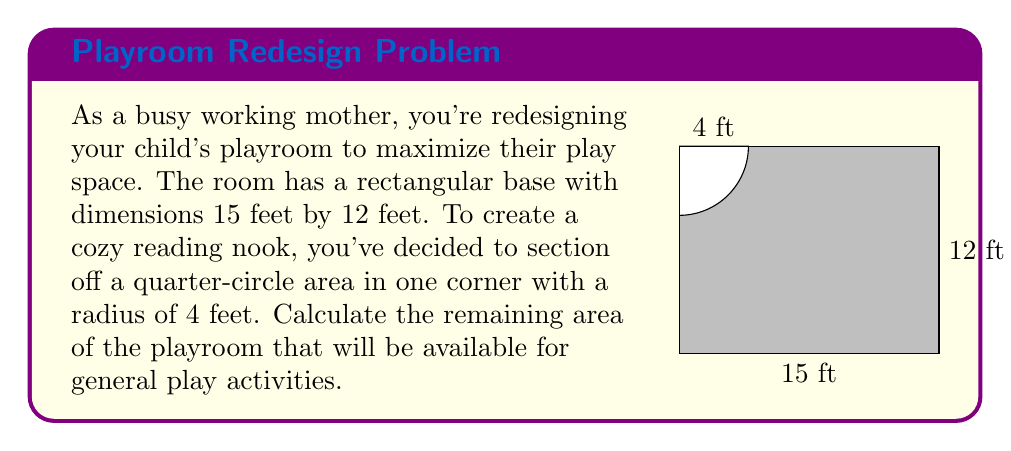Show me your answer to this math problem. Let's approach this problem step-by-step:

1) First, calculate the total area of the rectangular room:
   $A_{rectangle} = length \times width = 15 \text{ ft} \times 12 \text{ ft} = 180 \text{ sq ft}$

2) Next, calculate the area of the quarter-circle reading nook:
   $A_{quarter-circle} = \frac{1}{4} \times \pi r^2 = \frac{1}{4} \times \pi \times (4 \text{ ft})^2 = 4\pi \text{ sq ft}$

3) The remaining play area will be the difference between these two areas:
   $A_{play} = A_{rectangle} - A_{quarter-circle}$
   $A_{play} = 180 \text{ sq ft} - 4\pi \text{ sq ft}$

4) Simplify:
   $A_{play} = 180 - 4\pi \text{ sq ft}$
   $A_{play} \approx 167.43 \text{ sq ft}$

Therefore, the remaining area for general play activities is approximately 167.43 square feet.
Answer: $180 - 4\pi \text{ sq ft} \approx 167.43 \text{ sq ft}$ 